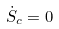<formula> <loc_0><loc_0><loc_500><loc_500>\dot { S } _ { c } = 0</formula> 